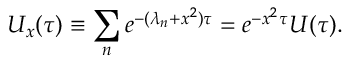Convert formula to latex. <formula><loc_0><loc_0><loc_500><loc_500>U _ { x } ( \tau ) \equiv \sum _ { n } e ^ { - ( \lambda _ { n } + x ^ { 2 } ) \tau } = e ^ { - x ^ { 2 } \tau } U ( \tau ) .</formula> 